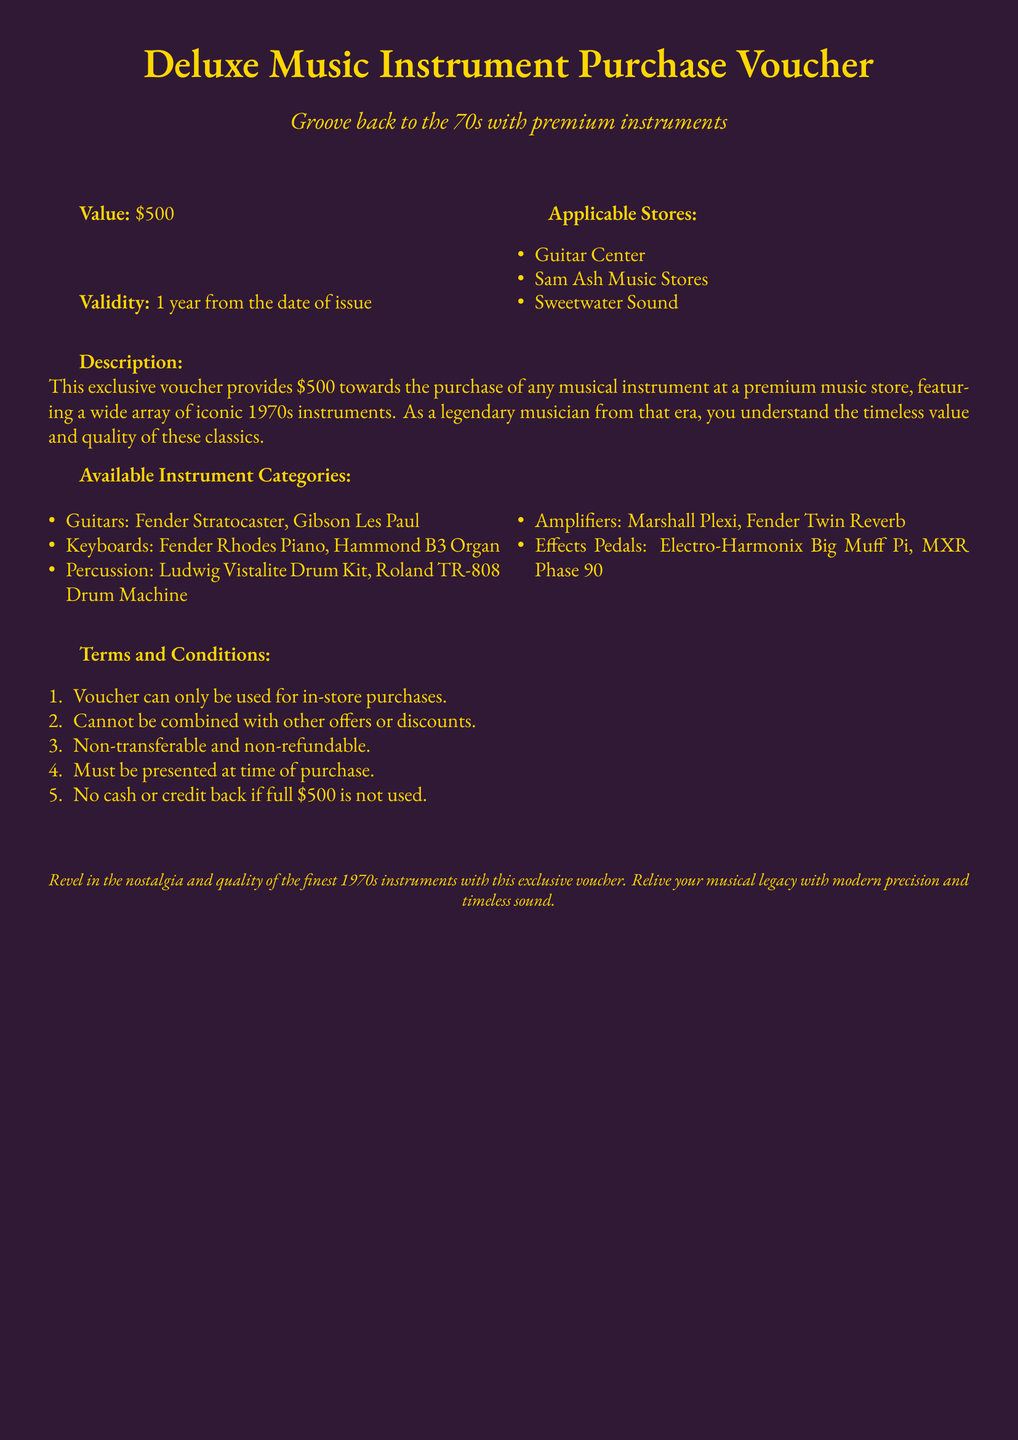What is the value of the voucher? The voucher value is stated clearly in the document as \$500.
Answer: \$500 What is the validity period of the voucher? The validity period is mentioned as 1 year from the date of issue.
Answer: 1 year Which stores can the voucher be used at? The document lists specific stores where the voucher is applicable: Guitar Center, Sam Ash Music Stores, and Sweetwater Sound.
Answer: Guitar Center, Sam Ash Music Stores, Sweetwater Sound What types of instruments are included in the voucher? The document outlines available instrument categories including guitars, keyboards, percussion, amplifiers, and effects pedals.
Answer: Guitars, Keyboards, Percussion, Amplifiers, Effects Pedals Can the voucher be combined with other offers? The terms and conditions state that the voucher cannot be combined with other offers or discounts.
Answer: No What must be presented at the time of purchase? The document specifies that the voucher must be presented at the time of purchase.
Answer: Voucher Is the voucher refundable? One of the terms indicates that the voucher is non-refundable.
Answer: No What iconic drum machine is available? The available percussion instruments include the Roland TR-808 Drum Machine.
Answer: Roland TR-808 Drum Machine What is the purpose of this voucher? The document describes the voucher as providing funds towards purchasing any musical instrument, emphasizing the 1970s instruments.
Answer: Purchase of musical instruments 